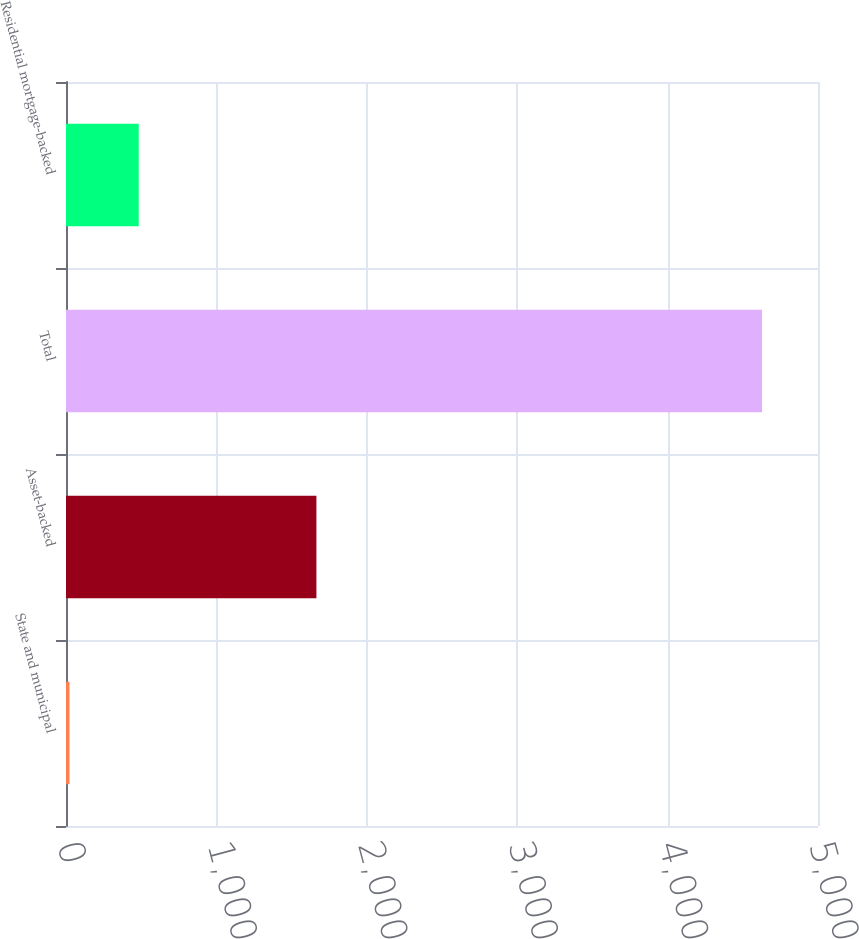Convert chart. <chart><loc_0><loc_0><loc_500><loc_500><bar_chart><fcel>State and municipal<fcel>Asset-backed<fcel>Total<fcel>Residential mortgage-backed<nl><fcel>23<fcel>1665<fcel>4628<fcel>483.5<nl></chart> 